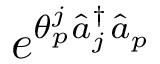<formula> <loc_0><loc_0><loc_500><loc_500>e ^ { \theta _ { p } ^ { j } \hat { a } _ { j } ^ { \dagger } \hat { a } _ { p } }</formula> 